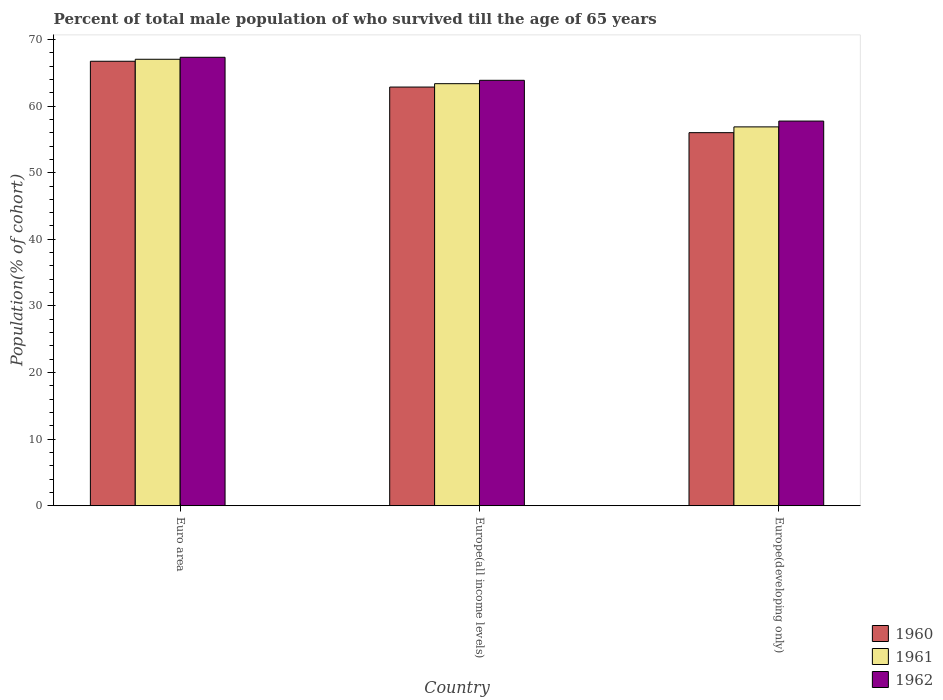How many different coloured bars are there?
Provide a succinct answer. 3. Are the number of bars on each tick of the X-axis equal?
Offer a terse response. Yes. What is the label of the 3rd group of bars from the left?
Keep it short and to the point. Europe(developing only). What is the percentage of total male population who survived till the age of 65 years in 1960 in Euro area?
Offer a very short reply. 66.73. Across all countries, what is the maximum percentage of total male population who survived till the age of 65 years in 1962?
Your answer should be very brief. 67.32. Across all countries, what is the minimum percentage of total male population who survived till the age of 65 years in 1961?
Your answer should be compact. 56.88. In which country was the percentage of total male population who survived till the age of 65 years in 1962 minimum?
Your response must be concise. Europe(developing only). What is the total percentage of total male population who survived till the age of 65 years in 1962 in the graph?
Offer a terse response. 188.94. What is the difference between the percentage of total male population who survived till the age of 65 years in 1960 in Euro area and that in Europe(all income levels)?
Make the answer very short. 3.87. What is the difference between the percentage of total male population who survived till the age of 65 years in 1960 in Europe(developing only) and the percentage of total male population who survived till the age of 65 years in 1962 in Euro area?
Your response must be concise. -11.31. What is the average percentage of total male population who survived till the age of 65 years in 1962 per country?
Offer a terse response. 62.98. What is the difference between the percentage of total male population who survived till the age of 65 years of/in 1962 and percentage of total male population who survived till the age of 65 years of/in 1961 in Europe(developing only)?
Make the answer very short. 0.87. What is the ratio of the percentage of total male population who survived till the age of 65 years in 1961 in Euro area to that in Europe(all income levels)?
Your response must be concise. 1.06. Is the percentage of total male population who survived till the age of 65 years in 1962 in Euro area less than that in Europe(all income levels)?
Provide a short and direct response. No. What is the difference between the highest and the second highest percentage of total male population who survived till the age of 65 years in 1960?
Your answer should be compact. -10.72. What is the difference between the highest and the lowest percentage of total male population who survived till the age of 65 years in 1961?
Make the answer very short. 10.15. What does the 2nd bar from the left in Europe(all income levels) represents?
Keep it short and to the point. 1961. What does the 3rd bar from the right in Europe(all income levels) represents?
Offer a very short reply. 1960. Is it the case that in every country, the sum of the percentage of total male population who survived till the age of 65 years in 1962 and percentage of total male population who survived till the age of 65 years in 1960 is greater than the percentage of total male population who survived till the age of 65 years in 1961?
Keep it short and to the point. Yes. How many countries are there in the graph?
Offer a terse response. 3. Are the values on the major ticks of Y-axis written in scientific E-notation?
Keep it short and to the point. No. How many legend labels are there?
Provide a short and direct response. 3. What is the title of the graph?
Offer a very short reply. Percent of total male population of who survived till the age of 65 years. What is the label or title of the Y-axis?
Make the answer very short. Population(% of cohort). What is the Population(% of cohort) of 1960 in Euro area?
Give a very brief answer. 66.73. What is the Population(% of cohort) in 1961 in Euro area?
Make the answer very short. 67.03. What is the Population(% of cohort) in 1962 in Euro area?
Make the answer very short. 67.32. What is the Population(% of cohort) in 1960 in Europe(all income levels)?
Provide a short and direct response. 62.85. What is the Population(% of cohort) of 1961 in Europe(all income levels)?
Provide a succinct answer. 63.36. What is the Population(% of cohort) in 1962 in Europe(all income levels)?
Provide a succinct answer. 63.87. What is the Population(% of cohort) of 1960 in Europe(developing only)?
Make the answer very short. 56.01. What is the Population(% of cohort) of 1961 in Europe(developing only)?
Make the answer very short. 56.88. What is the Population(% of cohort) in 1962 in Europe(developing only)?
Make the answer very short. 57.75. Across all countries, what is the maximum Population(% of cohort) of 1960?
Offer a very short reply. 66.73. Across all countries, what is the maximum Population(% of cohort) of 1961?
Provide a succinct answer. 67.03. Across all countries, what is the maximum Population(% of cohort) in 1962?
Offer a terse response. 67.32. Across all countries, what is the minimum Population(% of cohort) in 1960?
Provide a short and direct response. 56.01. Across all countries, what is the minimum Population(% of cohort) of 1961?
Make the answer very short. 56.88. Across all countries, what is the minimum Population(% of cohort) in 1962?
Provide a short and direct response. 57.75. What is the total Population(% of cohort) in 1960 in the graph?
Your answer should be compact. 185.59. What is the total Population(% of cohort) in 1961 in the graph?
Give a very brief answer. 187.26. What is the total Population(% of cohort) of 1962 in the graph?
Provide a succinct answer. 188.94. What is the difference between the Population(% of cohort) in 1960 in Euro area and that in Europe(all income levels)?
Provide a succinct answer. 3.87. What is the difference between the Population(% of cohort) of 1961 in Euro area and that in Europe(all income levels)?
Keep it short and to the point. 3.67. What is the difference between the Population(% of cohort) of 1962 in Euro area and that in Europe(all income levels)?
Your response must be concise. 3.45. What is the difference between the Population(% of cohort) in 1960 in Euro area and that in Europe(developing only)?
Ensure brevity in your answer.  10.72. What is the difference between the Population(% of cohort) in 1961 in Euro area and that in Europe(developing only)?
Provide a succinct answer. 10.15. What is the difference between the Population(% of cohort) of 1962 in Euro area and that in Europe(developing only)?
Offer a very short reply. 9.57. What is the difference between the Population(% of cohort) of 1960 in Europe(all income levels) and that in Europe(developing only)?
Your answer should be compact. 6.85. What is the difference between the Population(% of cohort) in 1961 in Europe(all income levels) and that in Europe(developing only)?
Provide a succinct answer. 6.49. What is the difference between the Population(% of cohort) of 1962 in Europe(all income levels) and that in Europe(developing only)?
Offer a terse response. 6.12. What is the difference between the Population(% of cohort) of 1960 in Euro area and the Population(% of cohort) of 1961 in Europe(all income levels)?
Provide a short and direct response. 3.37. What is the difference between the Population(% of cohort) of 1960 in Euro area and the Population(% of cohort) of 1962 in Europe(all income levels)?
Your answer should be very brief. 2.86. What is the difference between the Population(% of cohort) in 1961 in Euro area and the Population(% of cohort) in 1962 in Europe(all income levels)?
Your response must be concise. 3.16. What is the difference between the Population(% of cohort) of 1960 in Euro area and the Population(% of cohort) of 1961 in Europe(developing only)?
Provide a succinct answer. 9.85. What is the difference between the Population(% of cohort) in 1960 in Euro area and the Population(% of cohort) in 1962 in Europe(developing only)?
Your response must be concise. 8.98. What is the difference between the Population(% of cohort) in 1961 in Euro area and the Population(% of cohort) in 1962 in Europe(developing only)?
Provide a succinct answer. 9.28. What is the difference between the Population(% of cohort) in 1960 in Europe(all income levels) and the Population(% of cohort) in 1961 in Europe(developing only)?
Keep it short and to the point. 5.98. What is the difference between the Population(% of cohort) in 1960 in Europe(all income levels) and the Population(% of cohort) in 1962 in Europe(developing only)?
Your answer should be very brief. 5.11. What is the difference between the Population(% of cohort) in 1961 in Europe(all income levels) and the Population(% of cohort) in 1962 in Europe(developing only)?
Ensure brevity in your answer.  5.61. What is the average Population(% of cohort) of 1960 per country?
Provide a succinct answer. 61.86. What is the average Population(% of cohort) in 1961 per country?
Your response must be concise. 62.42. What is the average Population(% of cohort) in 1962 per country?
Your answer should be very brief. 62.98. What is the difference between the Population(% of cohort) of 1960 and Population(% of cohort) of 1961 in Euro area?
Give a very brief answer. -0.3. What is the difference between the Population(% of cohort) of 1960 and Population(% of cohort) of 1962 in Euro area?
Give a very brief answer. -0.59. What is the difference between the Population(% of cohort) of 1961 and Population(% of cohort) of 1962 in Euro area?
Your response must be concise. -0.3. What is the difference between the Population(% of cohort) in 1960 and Population(% of cohort) in 1961 in Europe(all income levels)?
Offer a terse response. -0.51. What is the difference between the Population(% of cohort) in 1960 and Population(% of cohort) in 1962 in Europe(all income levels)?
Your response must be concise. -1.01. What is the difference between the Population(% of cohort) of 1961 and Population(% of cohort) of 1962 in Europe(all income levels)?
Your answer should be very brief. -0.51. What is the difference between the Population(% of cohort) in 1960 and Population(% of cohort) in 1961 in Europe(developing only)?
Offer a very short reply. -0.87. What is the difference between the Population(% of cohort) of 1960 and Population(% of cohort) of 1962 in Europe(developing only)?
Give a very brief answer. -1.74. What is the difference between the Population(% of cohort) of 1961 and Population(% of cohort) of 1962 in Europe(developing only)?
Give a very brief answer. -0.87. What is the ratio of the Population(% of cohort) in 1960 in Euro area to that in Europe(all income levels)?
Offer a very short reply. 1.06. What is the ratio of the Population(% of cohort) of 1961 in Euro area to that in Europe(all income levels)?
Ensure brevity in your answer.  1.06. What is the ratio of the Population(% of cohort) in 1962 in Euro area to that in Europe(all income levels)?
Your answer should be very brief. 1.05. What is the ratio of the Population(% of cohort) of 1960 in Euro area to that in Europe(developing only)?
Make the answer very short. 1.19. What is the ratio of the Population(% of cohort) of 1961 in Euro area to that in Europe(developing only)?
Provide a short and direct response. 1.18. What is the ratio of the Population(% of cohort) of 1962 in Euro area to that in Europe(developing only)?
Your answer should be very brief. 1.17. What is the ratio of the Population(% of cohort) of 1960 in Europe(all income levels) to that in Europe(developing only)?
Keep it short and to the point. 1.12. What is the ratio of the Population(% of cohort) of 1961 in Europe(all income levels) to that in Europe(developing only)?
Give a very brief answer. 1.11. What is the ratio of the Population(% of cohort) of 1962 in Europe(all income levels) to that in Europe(developing only)?
Offer a terse response. 1.11. What is the difference between the highest and the second highest Population(% of cohort) in 1960?
Keep it short and to the point. 3.87. What is the difference between the highest and the second highest Population(% of cohort) of 1961?
Offer a very short reply. 3.67. What is the difference between the highest and the second highest Population(% of cohort) of 1962?
Give a very brief answer. 3.45. What is the difference between the highest and the lowest Population(% of cohort) in 1960?
Your answer should be compact. 10.72. What is the difference between the highest and the lowest Population(% of cohort) in 1961?
Ensure brevity in your answer.  10.15. What is the difference between the highest and the lowest Population(% of cohort) in 1962?
Make the answer very short. 9.57. 